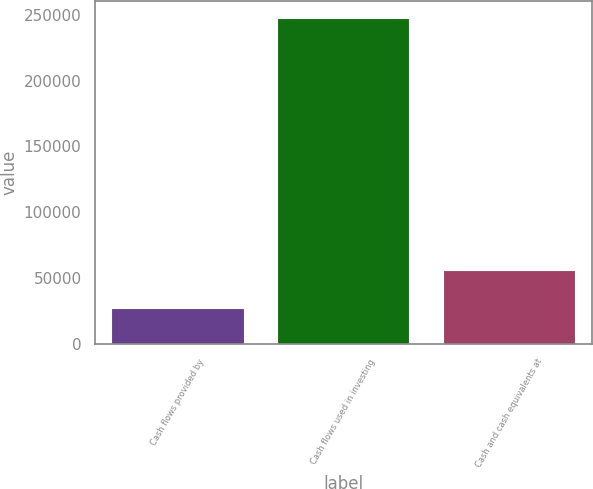Convert chart to OTSL. <chart><loc_0><loc_0><loc_500><loc_500><bar_chart><fcel>Cash flows provided by<fcel>Cash flows used in investing<fcel>Cash and cash equivalents at<nl><fcel>27098<fcel>247757<fcel>56292<nl></chart> 